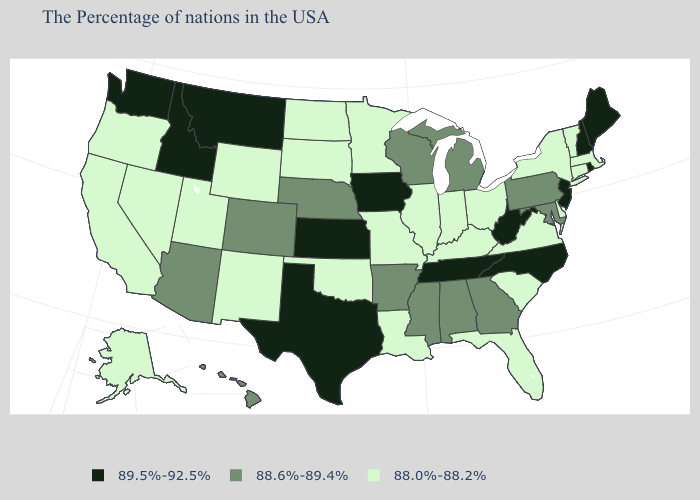What is the value of Minnesota?
Give a very brief answer. 88.0%-88.2%. Among the states that border Delaware , does New Jersey have the lowest value?
Answer briefly. No. Does Delaware have the lowest value in the USA?
Write a very short answer. Yes. What is the value of New Hampshire?
Concise answer only. 89.5%-92.5%. Does Alabama have the lowest value in the South?
Give a very brief answer. No. Name the states that have a value in the range 89.5%-92.5%?
Quick response, please. Maine, Rhode Island, New Hampshire, New Jersey, North Carolina, West Virginia, Tennessee, Iowa, Kansas, Texas, Montana, Idaho, Washington. What is the value of Utah?
Answer briefly. 88.0%-88.2%. Which states have the lowest value in the USA?
Quick response, please. Massachusetts, Vermont, Connecticut, New York, Delaware, Virginia, South Carolina, Ohio, Florida, Kentucky, Indiana, Illinois, Louisiana, Missouri, Minnesota, Oklahoma, South Dakota, North Dakota, Wyoming, New Mexico, Utah, Nevada, California, Oregon, Alaska. Name the states that have a value in the range 88.0%-88.2%?
Quick response, please. Massachusetts, Vermont, Connecticut, New York, Delaware, Virginia, South Carolina, Ohio, Florida, Kentucky, Indiana, Illinois, Louisiana, Missouri, Minnesota, Oklahoma, South Dakota, North Dakota, Wyoming, New Mexico, Utah, Nevada, California, Oregon, Alaska. What is the lowest value in states that border Alabama?
Quick response, please. 88.0%-88.2%. Which states have the lowest value in the South?
Answer briefly. Delaware, Virginia, South Carolina, Florida, Kentucky, Louisiana, Oklahoma. Is the legend a continuous bar?
Write a very short answer. No. Does Rhode Island have the lowest value in the Northeast?
Give a very brief answer. No. What is the value of Montana?
Be succinct. 89.5%-92.5%. What is the value of Indiana?
Quick response, please. 88.0%-88.2%. 